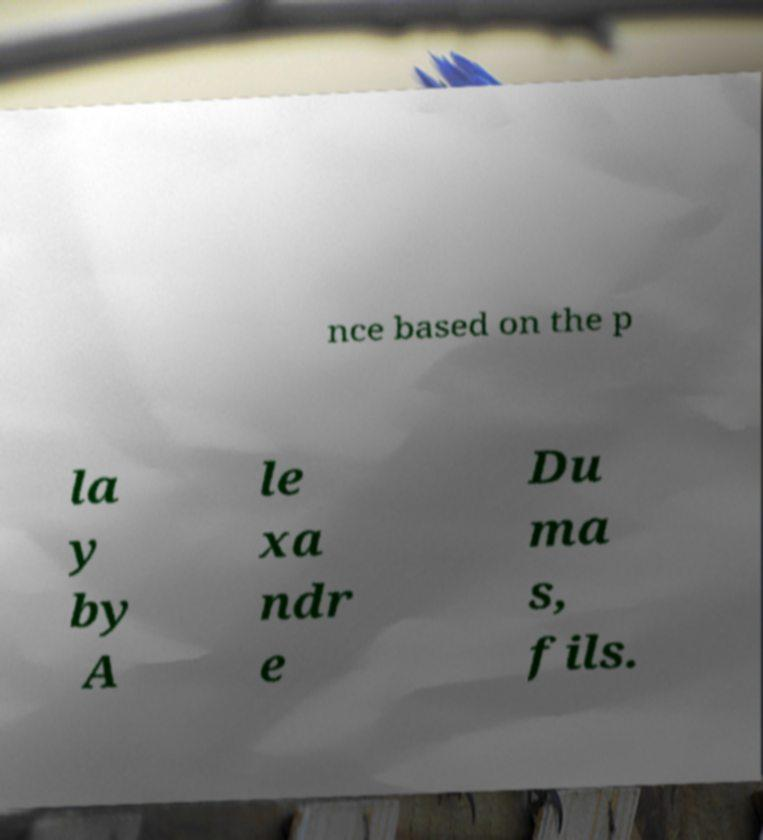Please identify and transcribe the text found in this image. nce based on the p la y by A le xa ndr e Du ma s, fils. 